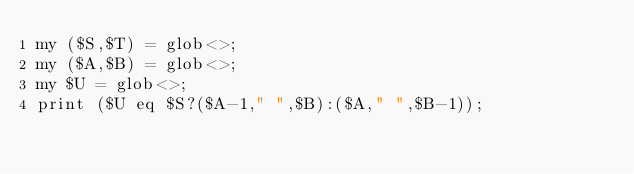<code> <loc_0><loc_0><loc_500><loc_500><_Perl_>my ($S,$T) = glob<>;
my ($A,$B) = glob<>;
my $U = glob<>;
print ($U eq $S?($A-1," ",$B):($A," ",$B-1));
</code> 